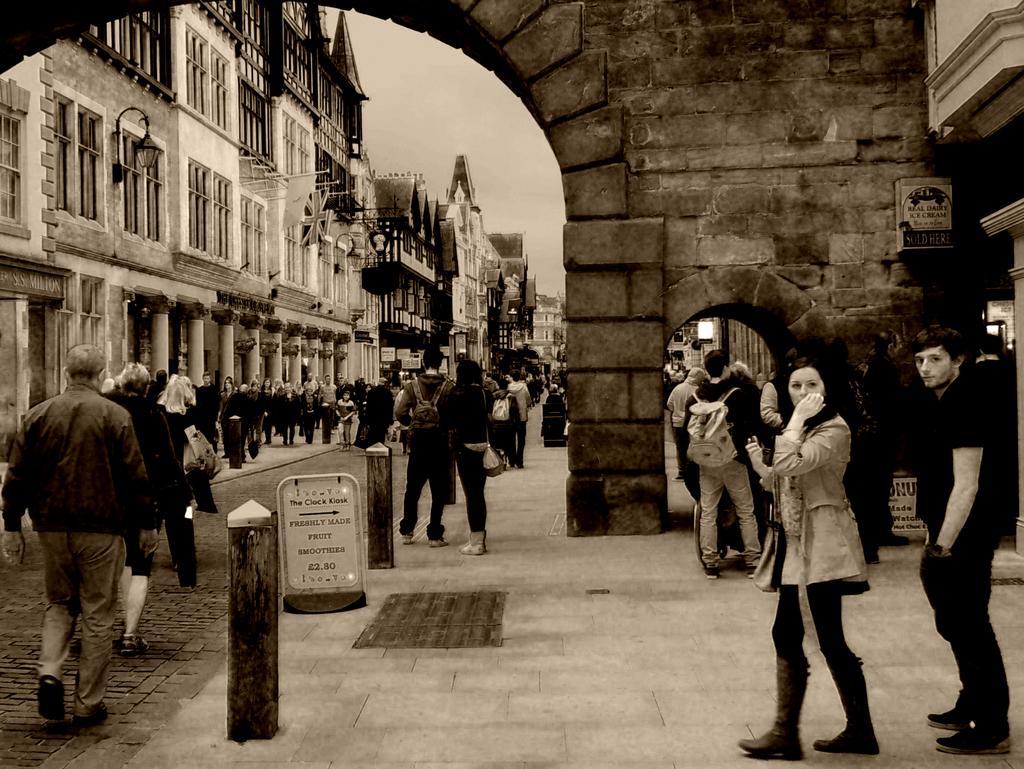Could you give a brief overview of what you see in this image? This is a black and white image , where there are group of people standing , there are buildings, boards, lights , and in the background there is sky. 